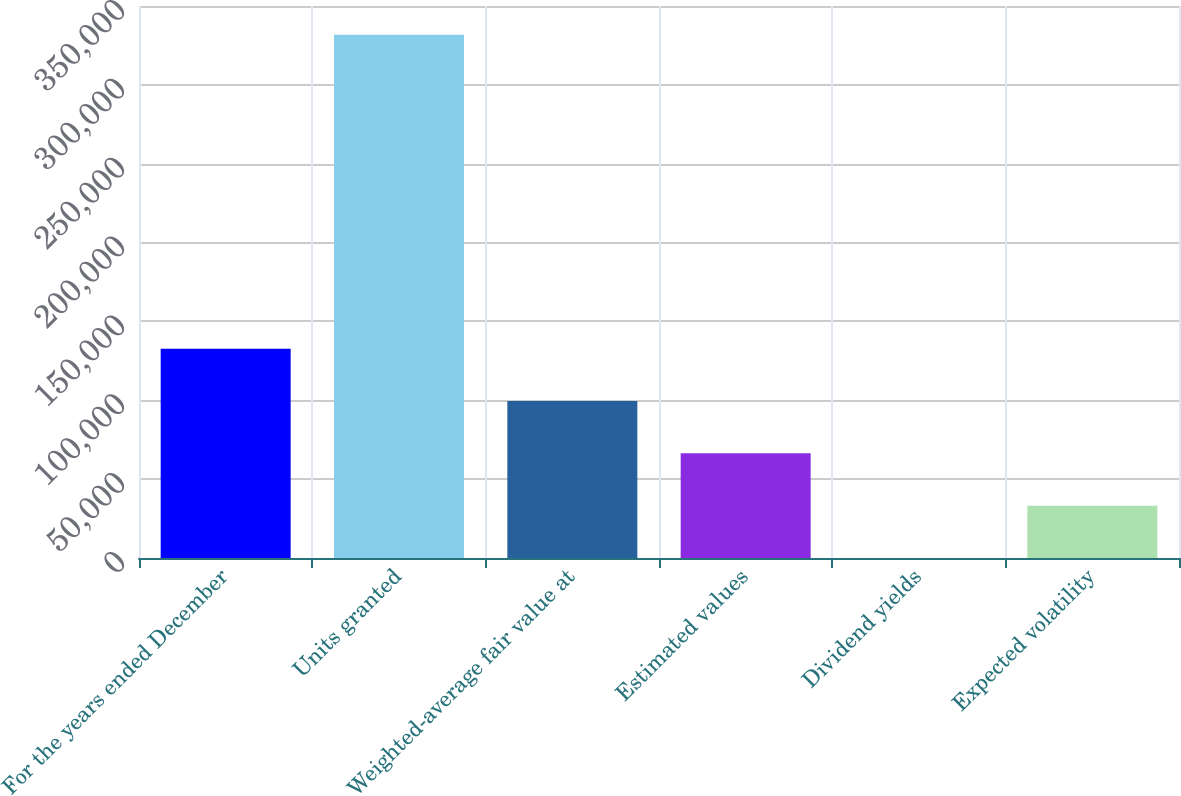<chart> <loc_0><loc_0><loc_500><loc_500><bar_chart><fcel>For the years ended December<fcel>Units granted<fcel>Weighted-average fair value at<fcel>Estimated values<fcel>Dividend yields<fcel>Expected volatility<nl><fcel>132716<fcel>331788<fcel>99537.7<fcel>66359<fcel>1.8<fcel>33180.4<nl></chart> 